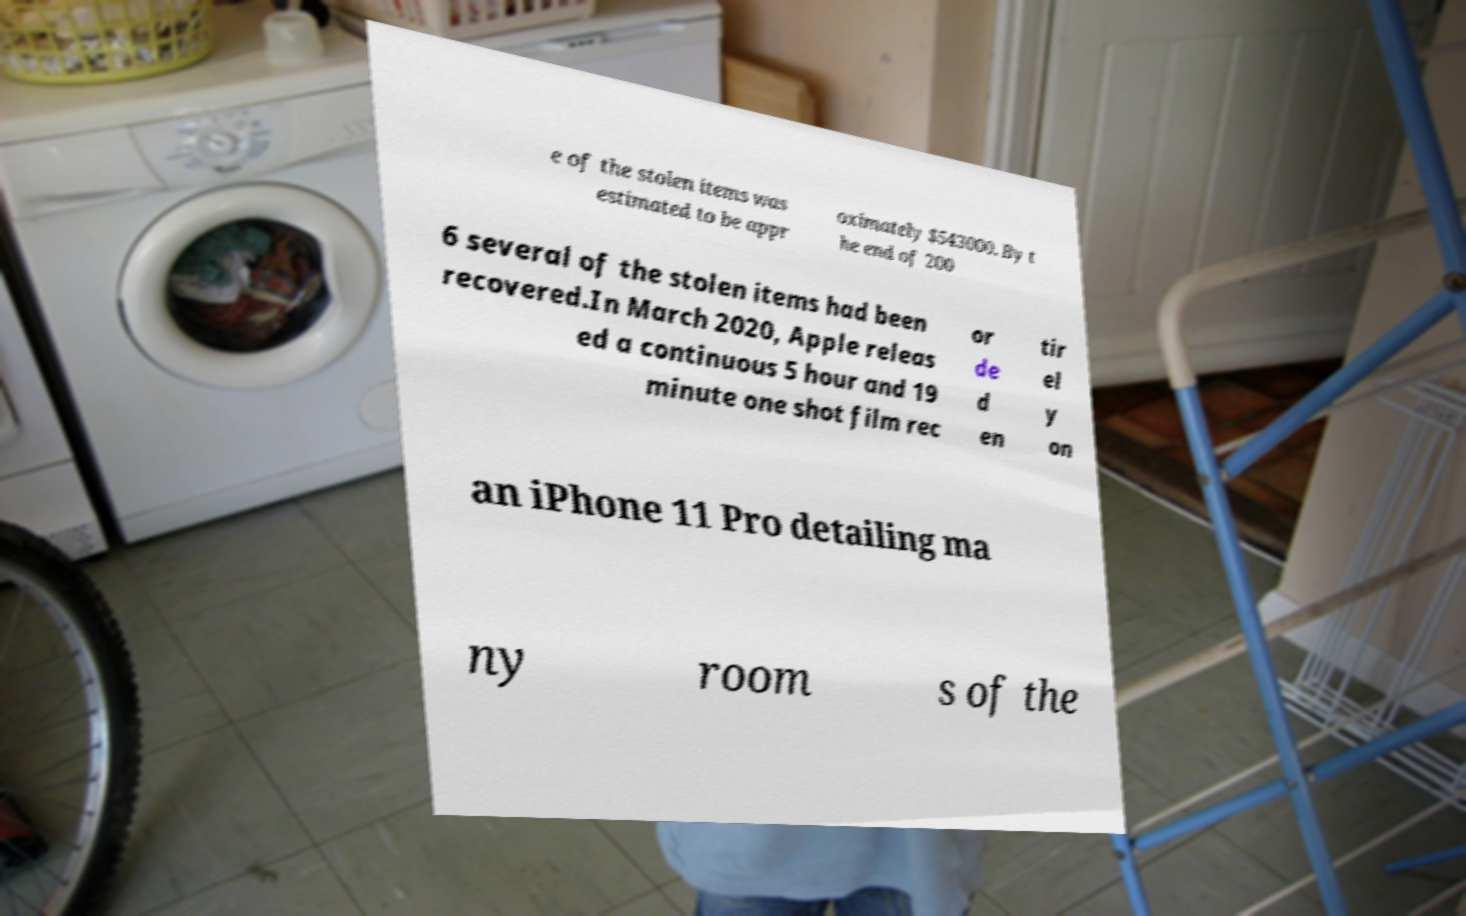I need the written content from this picture converted into text. Can you do that? e of the stolen items was estimated to be appr oximately $543000. By t he end of 200 6 several of the stolen items had been recovered.In March 2020, Apple releas ed a continuous 5 hour and 19 minute one shot film rec or de d en tir el y on an iPhone 11 Pro detailing ma ny room s of the 